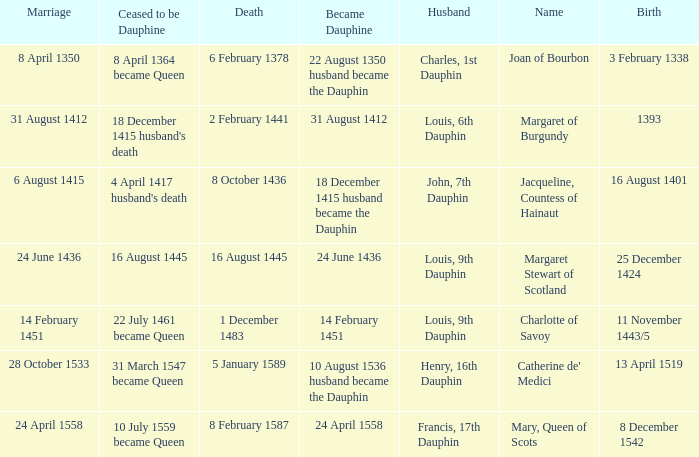Who has a birth of 16 august 1401? Jacqueline, Countess of Hainaut. 